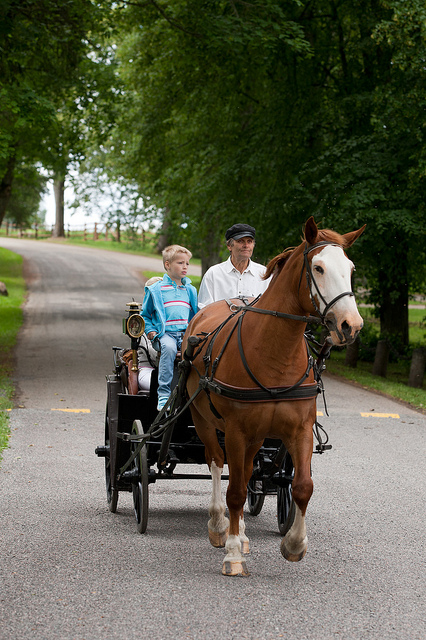<image>What makes this horse look funny? I don't know what makes this horse look funny. It might be the white face or its mouth. What makes this horse look funny? I don't know what makes this horse look funny. It can be nothing or its facial mark, white face, its mouth, or its feet. 